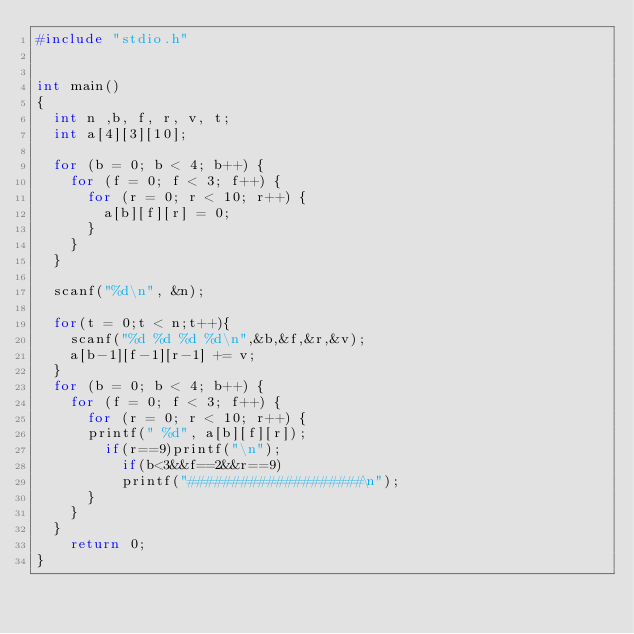Convert code to text. <code><loc_0><loc_0><loc_500><loc_500><_C_>#include "stdio.h"


int main()
{
	int n ,b, f, r, v, t;
	int a[4][3][10];

	for (b = 0; b < 4; b++) {
		for (f = 0; f < 3; f++) {
			for (r = 0; r < 10; r++) {
				a[b][f][r] = 0;
			}
		}
	}

	scanf("%d\n", &n);

	for(t = 0;t < n;t++){
		scanf("%d %d %d %d\n",&b,&f,&r,&v);
		a[b-1][f-1][r-1] += v;
	}
	for (b = 0; b < 4; b++) {
		for (f = 0; f < 3; f++) {
			for (r = 0; r < 10; r++) {
			printf(" %d", a[b][f][r]);
				if(r==9)printf("\n");
					if(b<3&&f==2&&r==9)
					printf("####################\n");
			}
		}
	}
    return 0;
}
</code> 